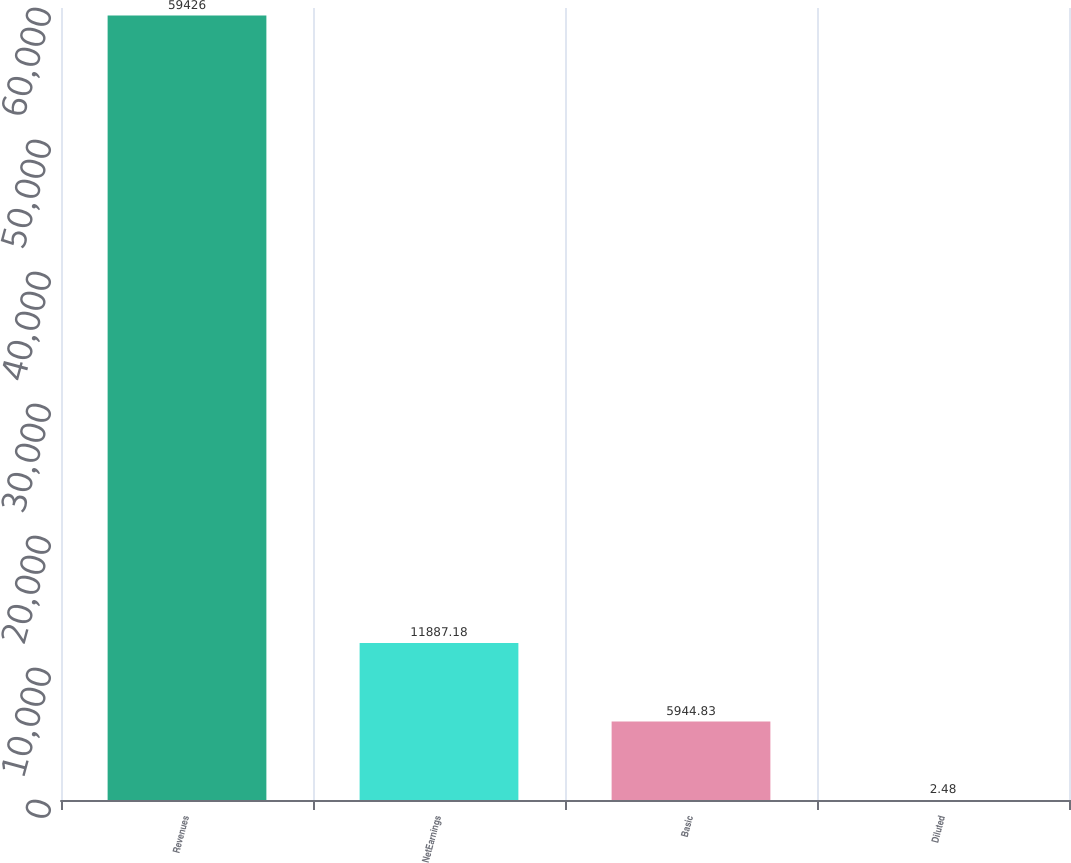Convert chart to OTSL. <chart><loc_0><loc_0><loc_500><loc_500><bar_chart><fcel>Revenues<fcel>NetEarnings<fcel>Basic<fcel>Diluted<nl><fcel>59426<fcel>11887.2<fcel>5944.83<fcel>2.48<nl></chart> 